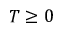Convert formula to latex. <formula><loc_0><loc_0><loc_500><loc_500>T \geq 0</formula> 